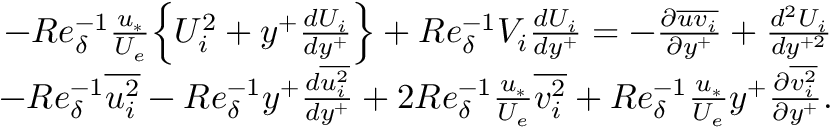<formula> <loc_0><loc_0><loc_500><loc_500>\begin{array} { r } { - R e _ { \delta } ^ { - 1 } \frac { u _ { * } } { U _ { e } } \left \{ U _ { i } ^ { 2 } + y ^ { + } \frac { d U _ { i } } { d y ^ { + } } \right \} + R e _ { \delta } ^ { - 1 } V _ { i } \frac { d U _ { i } } { d y ^ { + } } = - \frac { \partial \overline { { u v _ { i } } } } { \partial y ^ { + } } + \frac { d ^ { 2 } U _ { i } } { d y ^ { + 2 } } } \\ { - R e _ { \delta } ^ { - 1 } \overline { { u _ { i } ^ { 2 } } } - R e _ { \delta } ^ { - 1 } y ^ { + } \frac { d \overline { { u _ { i } ^ { 2 } } } } { d y ^ { + } } + 2 R e _ { \delta } ^ { - 1 } \frac { u _ { * } } { U _ { e } } \overline { { v _ { i } ^ { 2 } } } + R e _ { \delta } ^ { - 1 } \frac { u _ { * } } { U _ { e } } y ^ { + } \frac { \partial \overline { { v _ { i } ^ { 2 } } } } { \partial y ^ { + } } . } \end{array}</formula> 